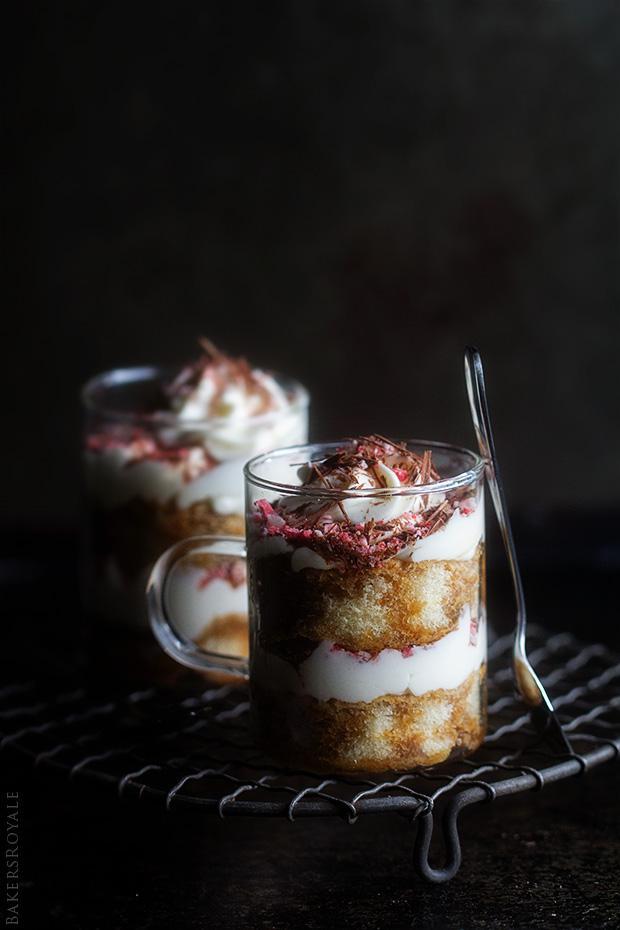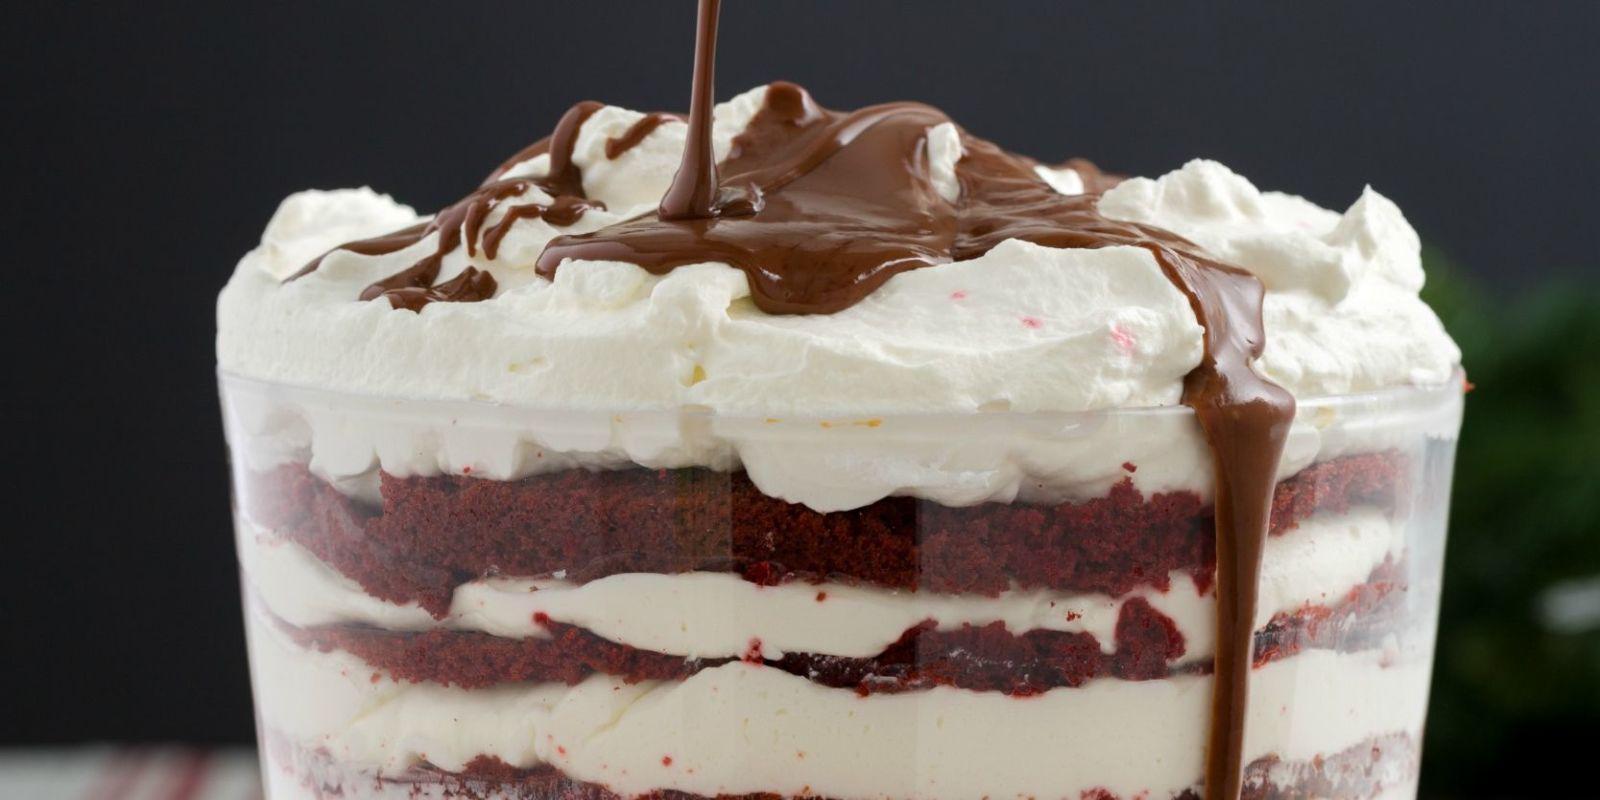The first image is the image on the left, the second image is the image on the right. Analyze the images presented: Is the assertion "Each dessert is being served in a large glass family sized portion." valid? Answer yes or no. No. The first image is the image on the left, the second image is the image on the right. Considering the images on both sides, is "Whole red raspberries garnish the top of at least one layered dessert served in a clear glass dish." valid? Answer yes or no. No. 